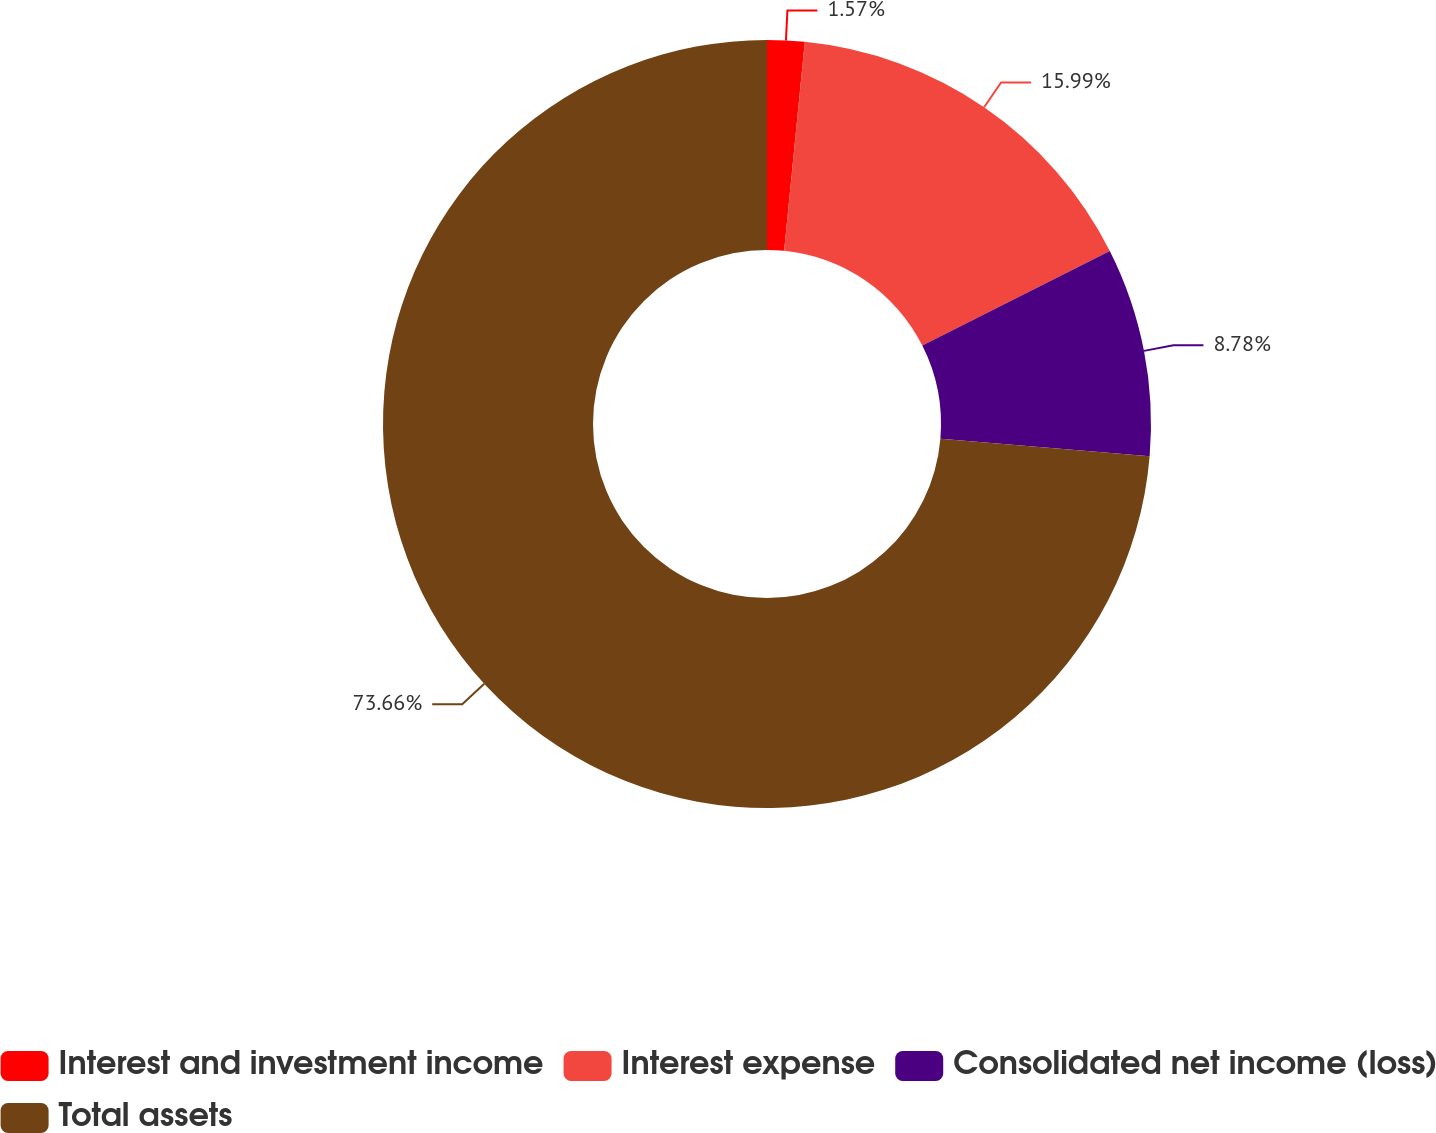<chart> <loc_0><loc_0><loc_500><loc_500><pie_chart><fcel>Interest and investment income<fcel>Interest expense<fcel>Consolidated net income (loss)<fcel>Total assets<nl><fcel>1.57%<fcel>15.99%<fcel>8.78%<fcel>73.66%<nl></chart> 